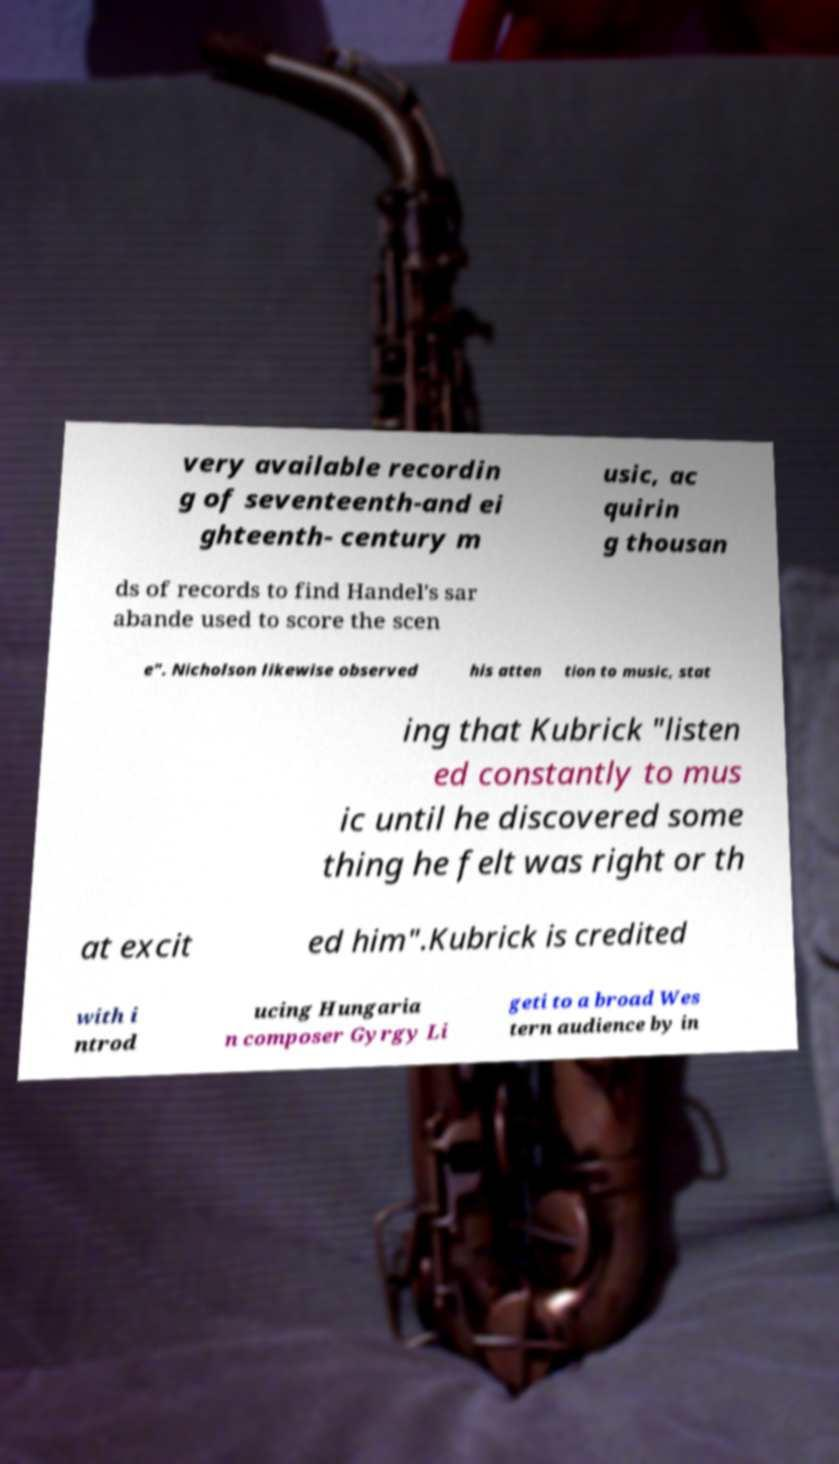Please identify and transcribe the text found in this image. very available recordin g of seventeenth-and ei ghteenth- century m usic, ac quirin g thousan ds of records to find Handel's sar abande used to score the scen e". Nicholson likewise observed his atten tion to music, stat ing that Kubrick "listen ed constantly to mus ic until he discovered some thing he felt was right or th at excit ed him".Kubrick is credited with i ntrod ucing Hungaria n composer Gyrgy Li geti to a broad Wes tern audience by in 